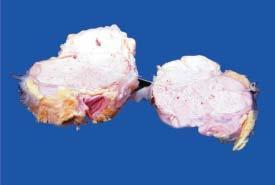did etastatic carcinomatous deposit in the mat mass of lymph nodes?
Answer the question using a single word or phrase. Yes 